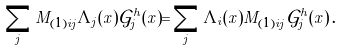Convert formula to latex. <formula><loc_0><loc_0><loc_500><loc_500>\sum _ { j } M _ { ( 1 ) i j } \Lambda _ { j } ( x ) \mathcal { G } ^ { h } _ { j } ( x ) = \sum _ { j } \Lambda _ { i } ( x ) M _ { ( 1 ) i j } \mathcal { G } ^ { h } _ { j } ( x ) \, .</formula> 